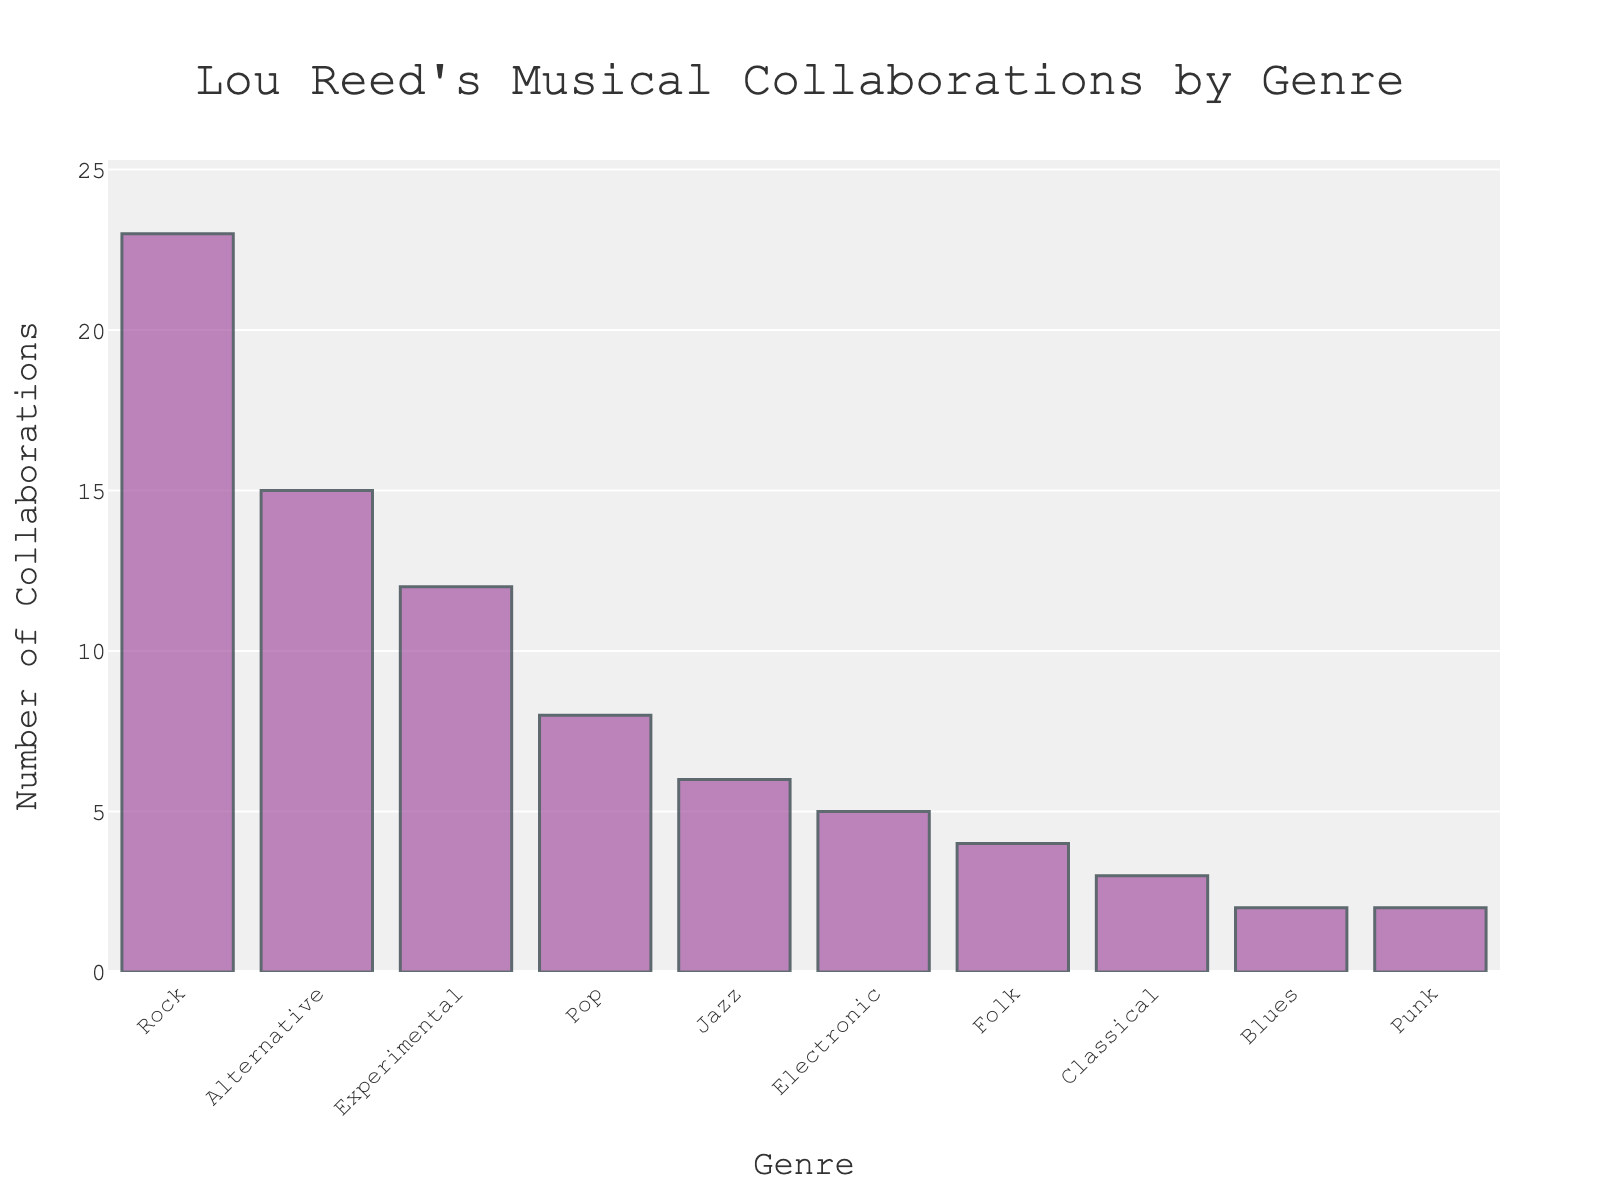Which genre has the highest number of collaborations? The bar labeled "Rock" has the highest height in the chart, indicating it has the most collaborations.
Answer: Rock How many more collaborations does the Rock genre have compared to the Electronic genre? The Rock genre has 23 collaborations and the Electronic genre has 5. Subtracting these values, 23 - 5 = 18.
Answer: 18 What is the difference in collaborations between the top two genres? The Rock genre has 23 collaborations and the Alternative genre has 15. Subtract the number of collaborations in Alternative from Rock, 23 - 15 = 8.
Answer: 8 What is the total number of collaborations across the bottom three genres? The bottom three genres (Classical, Blues, Punk) have 3, 2, and 2 collaborations respectively. Summing these values, 3 + 2 + 2 = 7.
Answer: 7 Which genre has the lowest number of collaborations? The genres Blues and Punk have the lowest height in the chart, indicating they have the least number of collaborations. Both have 2 collaborations each.
Answer: Blues and Punk What is the combined number of collaborations for Pop and Jazz genres? The Pop genre has 8 collaborations and the Jazz genre has 6. Summing these values, 8 + 6 = 14.
Answer: 14 How many genres have more than 10 collaborations? The genres Rock, Alternative, and Experimental each have more than 10 collaborations. That's 3 genres in total.
Answer: 3 Are there any genres with equal collaborations? If so, which ones? The genres Blues and Punk both have 2 collaborations, showing equal heights in the chart.
Answer: Blues and Punk What fraction of the total collaborations are in the Rock genre? The Rock genre has 23 out of the sum of all collaborations. Total collaborations = 23 + 15 + 12 + 8 + 6 + 5 + 4 + 3 + 2 + 2 = 80. The fraction is 23/80.
Answer: 23/80 (or approximately 0.2875) How many genres have fewer than 5 collaborations? The genres Folk, Classical, Blues, and Punk each have fewer than 5 collaborations. That's 4 genres in total.
Answer: 4 